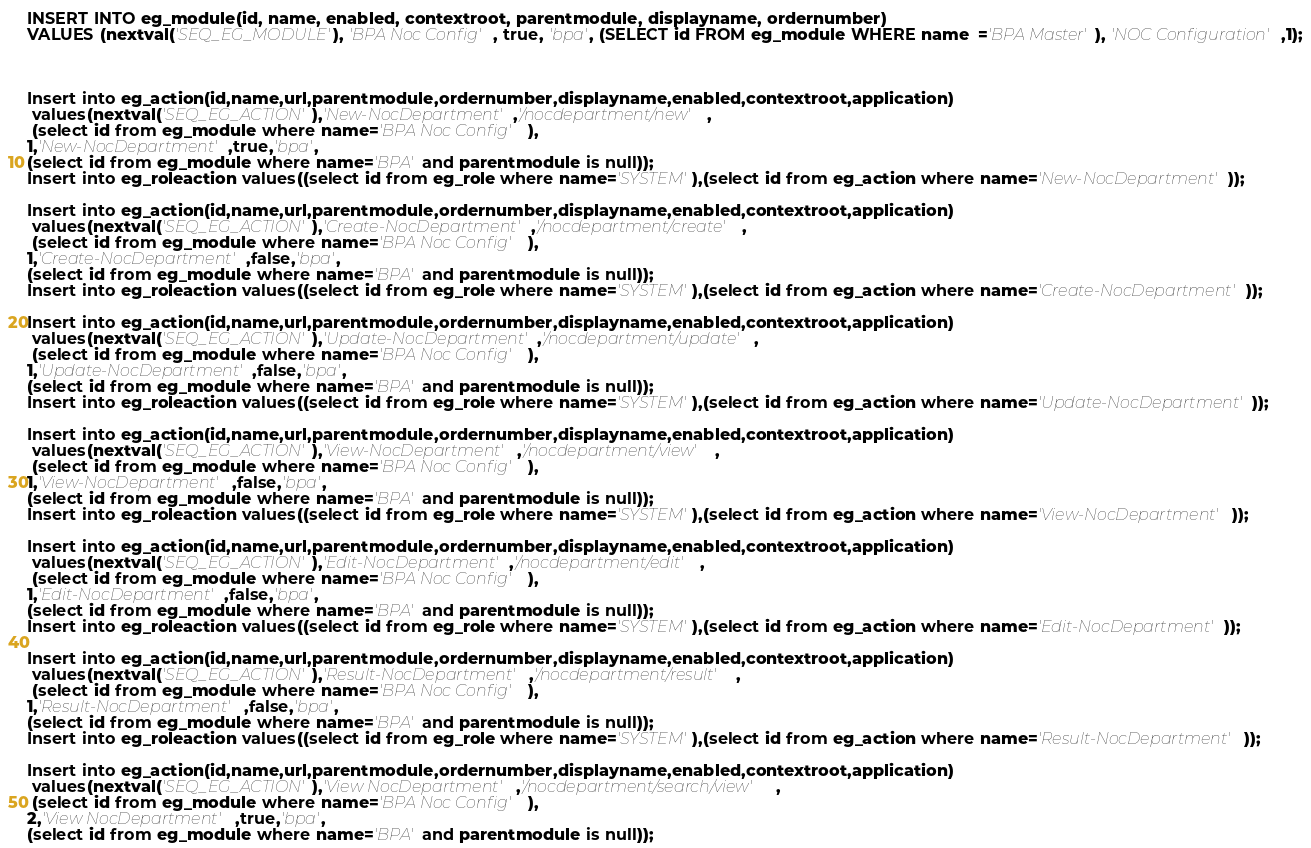<code> <loc_0><loc_0><loc_500><loc_500><_SQL_>INSERT INTO eg_module(id, name, enabled, contextroot, parentmodule, displayname, ordernumber)
VALUES (nextval('SEQ_EG_MODULE'), 'BPA Noc Config', true, 'bpa', (SELECT id FROM eg_module WHERE name  ='BPA Master'), 'NOC Configuration',1);



Insert into eg_action(id,name,url,parentmodule,ordernumber,displayname,enabled,contextroot,application)
 values(nextval('SEQ_EG_ACTION'),'New-NocDepartment','/nocdepartment/new',
 (select id from eg_module where name='BPA Noc Config' ),
1,'New-NocDepartment',true,'bpa',
(select id from eg_module where name='BPA' and parentmodule is null));
Insert into eg_roleaction values((select id from eg_role where name='SYSTEM'),(select id from eg_action where name='New-NocDepartment'));

Insert into eg_action(id,name,url,parentmodule,ordernumber,displayname,enabled,contextroot,application)
 values(nextval('SEQ_EG_ACTION'),'Create-NocDepartment','/nocdepartment/create',
 (select id from eg_module where name='BPA Noc Config' ),
1,'Create-NocDepartment',false,'bpa',
(select id from eg_module where name='BPA' and parentmodule is null));
Insert into eg_roleaction values((select id from eg_role where name='SYSTEM'),(select id from eg_action where name='Create-NocDepartment'));

Insert into eg_action(id,name,url,parentmodule,ordernumber,displayname,enabled,contextroot,application)
 values(nextval('SEQ_EG_ACTION'),'Update-NocDepartment','/nocdepartment/update',
 (select id from eg_module where name='BPA Noc Config' ),
1,'Update-NocDepartment',false,'bpa',
(select id from eg_module where name='BPA' and parentmodule is null));
Insert into eg_roleaction values((select id from eg_role where name='SYSTEM'),(select id from eg_action where name='Update-NocDepartment'));

Insert into eg_action(id,name,url,parentmodule,ordernumber,displayname,enabled,contextroot,application)
 values(nextval('SEQ_EG_ACTION'),'View-NocDepartment','/nocdepartment/view',
 (select id from eg_module where name='BPA Noc Config' ),
1,'View-NocDepartment',false,'bpa',
(select id from eg_module where name='BPA' and parentmodule is null));
Insert into eg_roleaction values((select id from eg_role where name='SYSTEM'),(select id from eg_action where name='View-NocDepartment'));

Insert into eg_action(id,name,url,parentmodule,ordernumber,displayname,enabled,contextroot,application)
 values(nextval('SEQ_EG_ACTION'),'Edit-NocDepartment','/nocdepartment/edit',
 (select id from eg_module where name='BPA Noc Config' ),
1,'Edit-NocDepartment',false,'bpa',
(select id from eg_module where name='BPA' and parentmodule is null));
Insert into eg_roleaction values((select id from eg_role where name='SYSTEM'),(select id from eg_action where name='Edit-NocDepartment'));

Insert into eg_action(id,name,url,parentmodule,ordernumber,displayname,enabled,contextroot,application)
 values(nextval('SEQ_EG_ACTION'),'Result-NocDepartment','/nocdepartment/result',
 (select id from eg_module where name='BPA Noc Config' ),
1,'Result-NocDepartment',false,'bpa',
(select id from eg_module where name='BPA' and parentmodule is null));
Insert into eg_roleaction values((select id from eg_role where name='SYSTEM'),(select id from eg_action where name='Result-NocDepartment'));

Insert into eg_action(id,name,url,parentmodule,ordernumber,displayname,enabled,contextroot,application)
 values(nextval('SEQ_EG_ACTION'),'View NocDepartment','/nocdepartment/search/view',
 (select id from eg_module where name='BPA Noc Config' ),
2,'View NocDepartment',true,'bpa',
(select id from eg_module where name='BPA' and parentmodule is null));</code> 